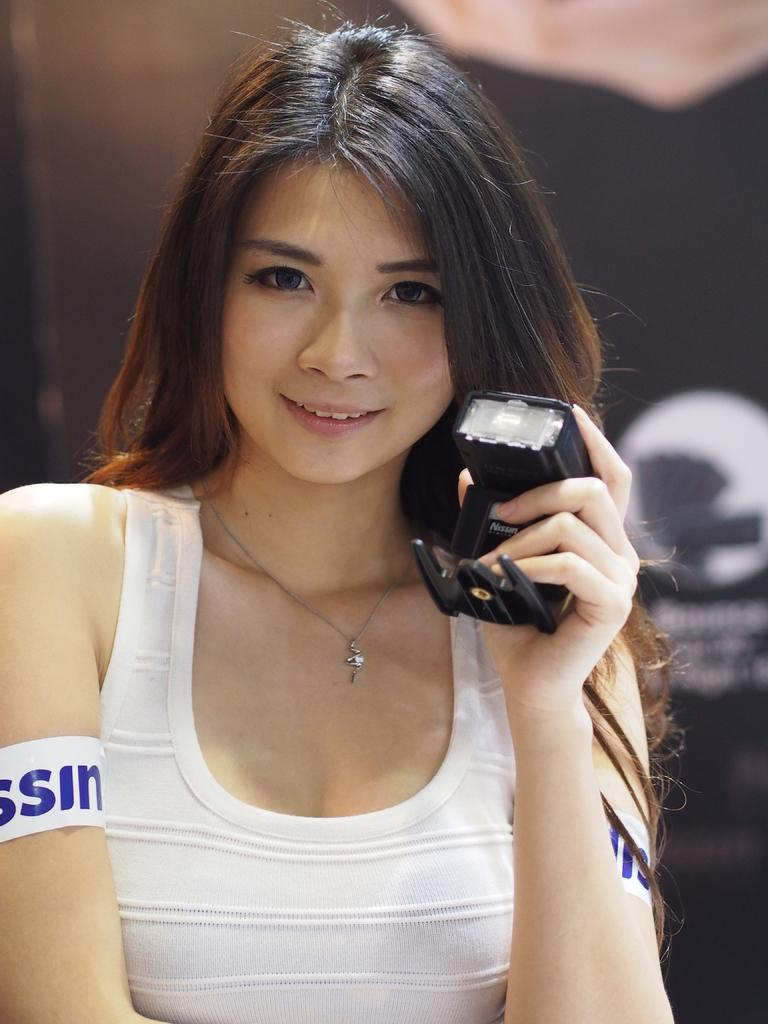Who is the main subject in the picture? There is a woman in the picture. What is the woman wearing? The woman is wearing a white top. What is the woman holding in her hand? The woman has something in her hand, but the specific object is not mentioned in the facts. What is the woman's facial expression? The woman is smiling. What type of pie is the woman holding in the image? There is no pie present in the image; the woman is holding something, but its identity is not specified in the facts. 